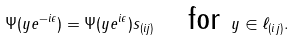<formula> <loc_0><loc_0><loc_500><loc_500>\Psi ( y e ^ { - i \epsilon } ) = \Psi ( y e ^ { i \epsilon } ) s _ { ( i j ) } \quad \text {for } y \in \ell _ { ( i j ) } .</formula> 